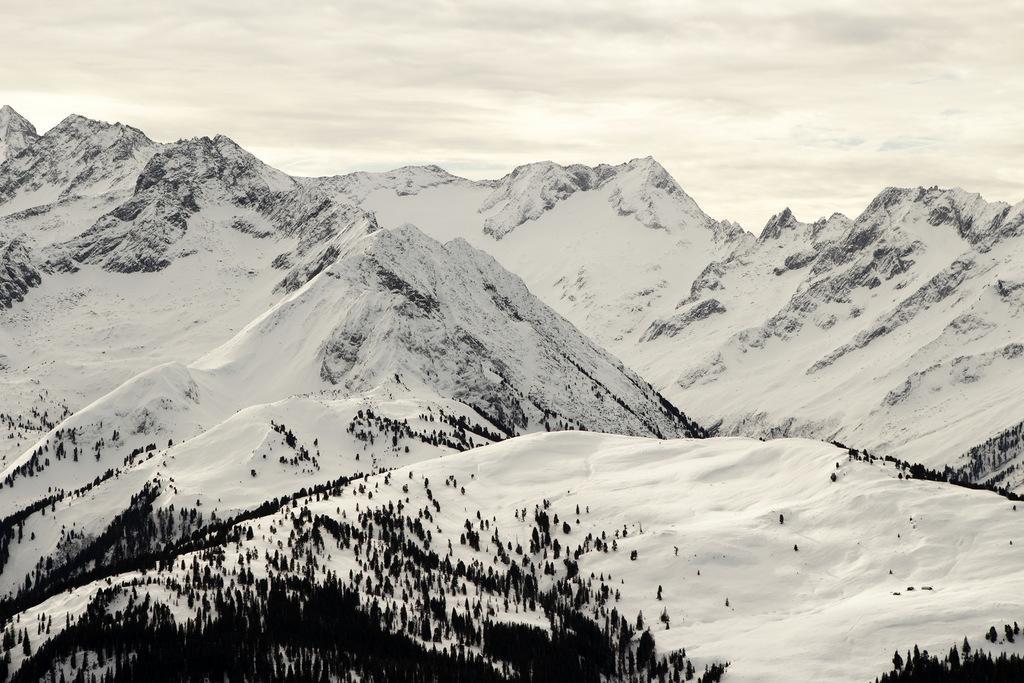Please provide a concise description of this image. In this image there are mountains. In the background there is sky. At the bottom there are trees and snow. 